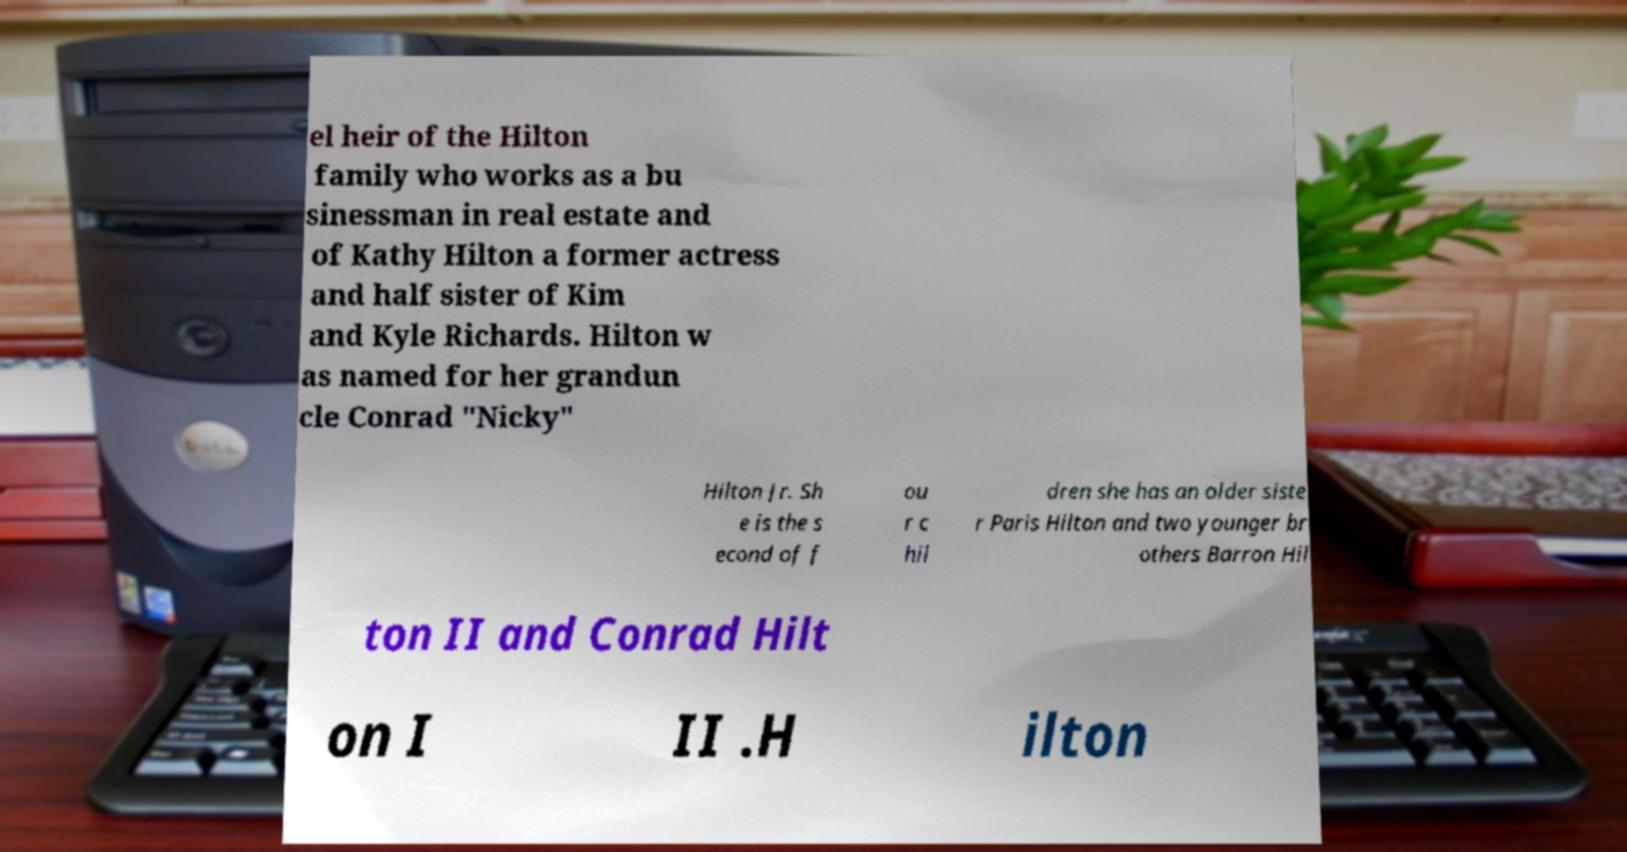Could you assist in decoding the text presented in this image and type it out clearly? el heir of the Hilton family who works as a bu sinessman in real estate and of Kathy Hilton a former actress and half sister of Kim and Kyle Richards. Hilton w as named for her grandun cle Conrad "Nicky" Hilton Jr. Sh e is the s econd of f ou r c hil dren she has an older siste r Paris Hilton and two younger br others Barron Hil ton II and Conrad Hilt on I II .H ilton 